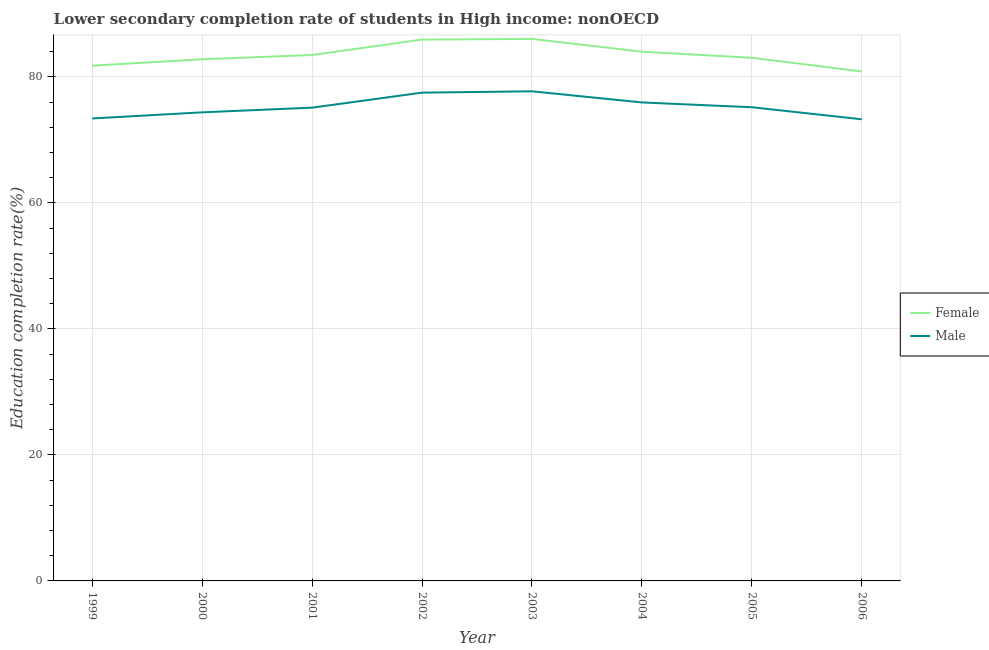Does the line corresponding to education completion rate of male students intersect with the line corresponding to education completion rate of female students?
Offer a very short reply. No. What is the education completion rate of female students in 2004?
Ensure brevity in your answer.  83.99. Across all years, what is the maximum education completion rate of male students?
Offer a very short reply. 77.71. Across all years, what is the minimum education completion rate of female students?
Your response must be concise. 80.86. In which year was the education completion rate of female students minimum?
Keep it short and to the point. 2006. What is the total education completion rate of male students in the graph?
Give a very brief answer. 602.51. What is the difference between the education completion rate of female students in 2002 and that in 2003?
Offer a very short reply. -0.11. What is the difference between the education completion rate of male students in 2000 and the education completion rate of female students in 1999?
Give a very brief answer. -7.41. What is the average education completion rate of male students per year?
Your answer should be compact. 75.31. In the year 2005, what is the difference between the education completion rate of male students and education completion rate of female students?
Provide a short and direct response. -7.86. What is the ratio of the education completion rate of female students in 2003 to that in 2004?
Make the answer very short. 1.02. Is the education completion rate of female students in 2001 less than that in 2005?
Provide a short and direct response. No. What is the difference between the highest and the second highest education completion rate of female students?
Your answer should be very brief. 0.11. What is the difference between the highest and the lowest education completion rate of male students?
Your answer should be very brief. 4.44. In how many years, is the education completion rate of female students greater than the average education completion rate of female students taken over all years?
Your answer should be very brief. 3. Is the education completion rate of female students strictly greater than the education completion rate of male students over the years?
Offer a terse response. Yes. How many lines are there?
Ensure brevity in your answer.  2. Does the graph contain any zero values?
Give a very brief answer. No. How many legend labels are there?
Offer a very short reply. 2. How are the legend labels stacked?
Your answer should be very brief. Vertical. What is the title of the graph?
Keep it short and to the point. Lower secondary completion rate of students in High income: nonOECD. What is the label or title of the X-axis?
Your answer should be very brief. Year. What is the label or title of the Y-axis?
Make the answer very short. Education completion rate(%). What is the Education completion rate(%) of Female in 1999?
Ensure brevity in your answer.  81.79. What is the Education completion rate(%) in Male in 1999?
Provide a succinct answer. 73.4. What is the Education completion rate(%) in Female in 2000?
Keep it short and to the point. 82.8. What is the Education completion rate(%) in Male in 2000?
Offer a terse response. 74.37. What is the Education completion rate(%) in Female in 2001?
Make the answer very short. 83.48. What is the Education completion rate(%) in Male in 2001?
Make the answer very short. 75.12. What is the Education completion rate(%) in Female in 2002?
Your answer should be very brief. 85.92. What is the Education completion rate(%) of Male in 2002?
Give a very brief answer. 77.5. What is the Education completion rate(%) of Female in 2003?
Keep it short and to the point. 86.03. What is the Education completion rate(%) in Male in 2003?
Offer a very short reply. 77.71. What is the Education completion rate(%) of Female in 2004?
Provide a short and direct response. 83.99. What is the Education completion rate(%) of Male in 2004?
Your answer should be compact. 75.95. What is the Education completion rate(%) in Female in 2005?
Provide a short and direct response. 83.04. What is the Education completion rate(%) in Male in 2005?
Your answer should be very brief. 75.18. What is the Education completion rate(%) of Female in 2006?
Keep it short and to the point. 80.86. What is the Education completion rate(%) of Male in 2006?
Your answer should be very brief. 73.27. Across all years, what is the maximum Education completion rate(%) of Female?
Your answer should be compact. 86.03. Across all years, what is the maximum Education completion rate(%) of Male?
Your response must be concise. 77.71. Across all years, what is the minimum Education completion rate(%) in Female?
Provide a succinct answer. 80.86. Across all years, what is the minimum Education completion rate(%) in Male?
Ensure brevity in your answer.  73.27. What is the total Education completion rate(%) in Female in the graph?
Keep it short and to the point. 667.9. What is the total Education completion rate(%) in Male in the graph?
Offer a very short reply. 602.51. What is the difference between the Education completion rate(%) in Female in 1999 and that in 2000?
Keep it short and to the point. -1.01. What is the difference between the Education completion rate(%) of Male in 1999 and that in 2000?
Your answer should be compact. -0.97. What is the difference between the Education completion rate(%) in Female in 1999 and that in 2001?
Provide a short and direct response. -1.69. What is the difference between the Education completion rate(%) of Male in 1999 and that in 2001?
Your answer should be compact. -1.71. What is the difference between the Education completion rate(%) in Female in 1999 and that in 2002?
Offer a terse response. -4.14. What is the difference between the Education completion rate(%) of Male in 1999 and that in 2002?
Your answer should be very brief. -4.1. What is the difference between the Education completion rate(%) of Female in 1999 and that in 2003?
Ensure brevity in your answer.  -4.25. What is the difference between the Education completion rate(%) in Male in 1999 and that in 2003?
Offer a terse response. -4.31. What is the difference between the Education completion rate(%) in Female in 1999 and that in 2004?
Make the answer very short. -2.21. What is the difference between the Education completion rate(%) of Male in 1999 and that in 2004?
Keep it short and to the point. -2.54. What is the difference between the Education completion rate(%) of Female in 1999 and that in 2005?
Provide a short and direct response. -1.25. What is the difference between the Education completion rate(%) in Male in 1999 and that in 2005?
Offer a terse response. -1.78. What is the difference between the Education completion rate(%) of Female in 1999 and that in 2006?
Offer a very short reply. 0.92. What is the difference between the Education completion rate(%) in Male in 1999 and that in 2006?
Give a very brief answer. 0.13. What is the difference between the Education completion rate(%) in Female in 2000 and that in 2001?
Ensure brevity in your answer.  -0.68. What is the difference between the Education completion rate(%) in Male in 2000 and that in 2001?
Give a very brief answer. -0.74. What is the difference between the Education completion rate(%) in Female in 2000 and that in 2002?
Provide a short and direct response. -3.13. What is the difference between the Education completion rate(%) in Male in 2000 and that in 2002?
Ensure brevity in your answer.  -3.13. What is the difference between the Education completion rate(%) in Female in 2000 and that in 2003?
Offer a very short reply. -3.23. What is the difference between the Education completion rate(%) of Male in 2000 and that in 2003?
Ensure brevity in your answer.  -3.34. What is the difference between the Education completion rate(%) in Female in 2000 and that in 2004?
Give a very brief answer. -1.2. What is the difference between the Education completion rate(%) in Male in 2000 and that in 2004?
Your answer should be compact. -1.57. What is the difference between the Education completion rate(%) in Female in 2000 and that in 2005?
Provide a short and direct response. -0.24. What is the difference between the Education completion rate(%) in Male in 2000 and that in 2005?
Ensure brevity in your answer.  -0.81. What is the difference between the Education completion rate(%) of Female in 2000 and that in 2006?
Provide a short and direct response. 1.94. What is the difference between the Education completion rate(%) in Male in 2000 and that in 2006?
Provide a short and direct response. 1.1. What is the difference between the Education completion rate(%) of Female in 2001 and that in 2002?
Offer a very short reply. -2.45. What is the difference between the Education completion rate(%) in Male in 2001 and that in 2002?
Keep it short and to the point. -2.38. What is the difference between the Education completion rate(%) of Female in 2001 and that in 2003?
Give a very brief answer. -2.56. What is the difference between the Education completion rate(%) of Male in 2001 and that in 2003?
Your response must be concise. -2.59. What is the difference between the Education completion rate(%) of Female in 2001 and that in 2004?
Provide a succinct answer. -0.52. What is the difference between the Education completion rate(%) of Male in 2001 and that in 2004?
Give a very brief answer. -0.83. What is the difference between the Education completion rate(%) of Female in 2001 and that in 2005?
Keep it short and to the point. 0.44. What is the difference between the Education completion rate(%) of Male in 2001 and that in 2005?
Your answer should be compact. -0.07. What is the difference between the Education completion rate(%) in Female in 2001 and that in 2006?
Make the answer very short. 2.61. What is the difference between the Education completion rate(%) in Male in 2001 and that in 2006?
Provide a short and direct response. 1.85. What is the difference between the Education completion rate(%) of Female in 2002 and that in 2003?
Your answer should be very brief. -0.11. What is the difference between the Education completion rate(%) in Male in 2002 and that in 2003?
Your answer should be compact. -0.21. What is the difference between the Education completion rate(%) of Female in 2002 and that in 2004?
Your answer should be compact. 1.93. What is the difference between the Education completion rate(%) in Male in 2002 and that in 2004?
Ensure brevity in your answer.  1.55. What is the difference between the Education completion rate(%) of Female in 2002 and that in 2005?
Ensure brevity in your answer.  2.88. What is the difference between the Education completion rate(%) in Male in 2002 and that in 2005?
Offer a very short reply. 2.32. What is the difference between the Education completion rate(%) of Female in 2002 and that in 2006?
Offer a terse response. 5.06. What is the difference between the Education completion rate(%) in Male in 2002 and that in 2006?
Ensure brevity in your answer.  4.23. What is the difference between the Education completion rate(%) in Female in 2003 and that in 2004?
Give a very brief answer. 2.04. What is the difference between the Education completion rate(%) of Male in 2003 and that in 2004?
Provide a succinct answer. 1.77. What is the difference between the Education completion rate(%) in Female in 2003 and that in 2005?
Your answer should be very brief. 2.99. What is the difference between the Education completion rate(%) of Male in 2003 and that in 2005?
Offer a terse response. 2.53. What is the difference between the Education completion rate(%) in Female in 2003 and that in 2006?
Ensure brevity in your answer.  5.17. What is the difference between the Education completion rate(%) in Male in 2003 and that in 2006?
Offer a very short reply. 4.44. What is the difference between the Education completion rate(%) of Female in 2004 and that in 2005?
Your answer should be very brief. 0.96. What is the difference between the Education completion rate(%) of Male in 2004 and that in 2005?
Provide a short and direct response. 0.76. What is the difference between the Education completion rate(%) of Female in 2004 and that in 2006?
Offer a very short reply. 3.13. What is the difference between the Education completion rate(%) in Male in 2004 and that in 2006?
Your answer should be very brief. 2.68. What is the difference between the Education completion rate(%) of Female in 2005 and that in 2006?
Keep it short and to the point. 2.18. What is the difference between the Education completion rate(%) in Male in 2005 and that in 2006?
Your answer should be compact. 1.91. What is the difference between the Education completion rate(%) in Female in 1999 and the Education completion rate(%) in Male in 2000?
Provide a succinct answer. 7.41. What is the difference between the Education completion rate(%) in Female in 1999 and the Education completion rate(%) in Male in 2001?
Make the answer very short. 6.67. What is the difference between the Education completion rate(%) in Female in 1999 and the Education completion rate(%) in Male in 2002?
Make the answer very short. 4.28. What is the difference between the Education completion rate(%) of Female in 1999 and the Education completion rate(%) of Male in 2003?
Your answer should be compact. 4.07. What is the difference between the Education completion rate(%) of Female in 1999 and the Education completion rate(%) of Male in 2004?
Offer a terse response. 5.84. What is the difference between the Education completion rate(%) of Female in 1999 and the Education completion rate(%) of Male in 2005?
Provide a succinct answer. 6.6. What is the difference between the Education completion rate(%) of Female in 1999 and the Education completion rate(%) of Male in 2006?
Provide a short and direct response. 8.51. What is the difference between the Education completion rate(%) of Female in 2000 and the Education completion rate(%) of Male in 2001?
Keep it short and to the point. 7.68. What is the difference between the Education completion rate(%) of Female in 2000 and the Education completion rate(%) of Male in 2002?
Make the answer very short. 5.3. What is the difference between the Education completion rate(%) in Female in 2000 and the Education completion rate(%) in Male in 2003?
Provide a succinct answer. 5.08. What is the difference between the Education completion rate(%) in Female in 2000 and the Education completion rate(%) in Male in 2004?
Your answer should be very brief. 6.85. What is the difference between the Education completion rate(%) in Female in 2000 and the Education completion rate(%) in Male in 2005?
Offer a terse response. 7.61. What is the difference between the Education completion rate(%) of Female in 2000 and the Education completion rate(%) of Male in 2006?
Offer a terse response. 9.53. What is the difference between the Education completion rate(%) in Female in 2001 and the Education completion rate(%) in Male in 2002?
Provide a short and direct response. 5.98. What is the difference between the Education completion rate(%) of Female in 2001 and the Education completion rate(%) of Male in 2003?
Provide a short and direct response. 5.76. What is the difference between the Education completion rate(%) of Female in 2001 and the Education completion rate(%) of Male in 2004?
Offer a very short reply. 7.53. What is the difference between the Education completion rate(%) in Female in 2001 and the Education completion rate(%) in Male in 2005?
Your answer should be compact. 8.29. What is the difference between the Education completion rate(%) of Female in 2001 and the Education completion rate(%) of Male in 2006?
Your answer should be compact. 10.21. What is the difference between the Education completion rate(%) in Female in 2002 and the Education completion rate(%) in Male in 2003?
Keep it short and to the point. 8.21. What is the difference between the Education completion rate(%) of Female in 2002 and the Education completion rate(%) of Male in 2004?
Provide a succinct answer. 9.98. What is the difference between the Education completion rate(%) of Female in 2002 and the Education completion rate(%) of Male in 2005?
Ensure brevity in your answer.  10.74. What is the difference between the Education completion rate(%) in Female in 2002 and the Education completion rate(%) in Male in 2006?
Your response must be concise. 12.65. What is the difference between the Education completion rate(%) of Female in 2003 and the Education completion rate(%) of Male in 2004?
Keep it short and to the point. 10.09. What is the difference between the Education completion rate(%) of Female in 2003 and the Education completion rate(%) of Male in 2005?
Keep it short and to the point. 10.85. What is the difference between the Education completion rate(%) of Female in 2003 and the Education completion rate(%) of Male in 2006?
Offer a very short reply. 12.76. What is the difference between the Education completion rate(%) of Female in 2004 and the Education completion rate(%) of Male in 2005?
Offer a terse response. 8.81. What is the difference between the Education completion rate(%) in Female in 2004 and the Education completion rate(%) in Male in 2006?
Offer a very short reply. 10.72. What is the difference between the Education completion rate(%) in Female in 2005 and the Education completion rate(%) in Male in 2006?
Keep it short and to the point. 9.77. What is the average Education completion rate(%) of Female per year?
Provide a short and direct response. 83.49. What is the average Education completion rate(%) in Male per year?
Make the answer very short. 75.31. In the year 1999, what is the difference between the Education completion rate(%) of Female and Education completion rate(%) of Male?
Your answer should be very brief. 8.38. In the year 2000, what is the difference between the Education completion rate(%) of Female and Education completion rate(%) of Male?
Offer a very short reply. 8.42. In the year 2001, what is the difference between the Education completion rate(%) of Female and Education completion rate(%) of Male?
Offer a terse response. 8.36. In the year 2002, what is the difference between the Education completion rate(%) of Female and Education completion rate(%) of Male?
Your response must be concise. 8.42. In the year 2003, what is the difference between the Education completion rate(%) in Female and Education completion rate(%) in Male?
Offer a very short reply. 8.32. In the year 2004, what is the difference between the Education completion rate(%) in Female and Education completion rate(%) in Male?
Make the answer very short. 8.05. In the year 2005, what is the difference between the Education completion rate(%) of Female and Education completion rate(%) of Male?
Offer a very short reply. 7.86. In the year 2006, what is the difference between the Education completion rate(%) in Female and Education completion rate(%) in Male?
Ensure brevity in your answer.  7.59. What is the ratio of the Education completion rate(%) of Female in 1999 to that in 2000?
Offer a very short reply. 0.99. What is the ratio of the Education completion rate(%) in Male in 1999 to that in 2000?
Make the answer very short. 0.99. What is the ratio of the Education completion rate(%) in Female in 1999 to that in 2001?
Offer a terse response. 0.98. What is the ratio of the Education completion rate(%) of Male in 1999 to that in 2001?
Offer a terse response. 0.98. What is the ratio of the Education completion rate(%) in Female in 1999 to that in 2002?
Your response must be concise. 0.95. What is the ratio of the Education completion rate(%) in Male in 1999 to that in 2002?
Your answer should be very brief. 0.95. What is the ratio of the Education completion rate(%) of Female in 1999 to that in 2003?
Keep it short and to the point. 0.95. What is the ratio of the Education completion rate(%) in Male in 1999 to that in 2003?
Make the answer very short. 0.94. What is the ratio of the Education completion rate(%) in Female in 1999 to that in 2004?
Your answer should be compact. 0.97. What is the ratio of the Education completion rate(%) of Male in 1999 to that in 2004?
Your answer should be very brief. 0.97. What is the ratio of the Education completion rate(%) in Female in 1999 to that in 2005?
Offer a very short reply. 0.98. What is the ratio of the Education completion rate(%) in Male in 1999 to that in 2005?
Your response must be concise. 0.98. What is the ratio of the Education completion rate(%) in Female in 1999 to that in 2006?
Make the answer very short. 1.01. What is the ratio of the Education completion rate(%) of Male in 1999 to that in 2006?
Make the answer very short. 1. What is the ratio of the Education completion rate(%) of Male in 2000 to that in 2001?
Make the answer very short. 0.99. What is the ratio of the Education completion rate(%) of Female in 2000 to that in 2002?
Your answer should be compact. 0.96. What is the ratio of the Education completion rate(%) in Male in 2000 to that in 2002?
Offer a very short reply. 0.96. What is the ratio of the Education completion rate(%) of Female in 2000 to that in 2003?
Offer a very short reply. 0.96. What is the ratio of the Education completion rate(%) in Male in 2000 to that in 2003?
Make the answer very short. 0.96. What is the ratio of the Education completion rate(%) in Female in 2000 to that in 2004?
Your response must be concise. 0.99. What is the ratio of the Education completion rate(%) of Male in 2000 to that in 2004?
Ensure brevity in your answer.  0.98. What is the ratio of the Education completion rate(%) of Male in 2000 to that in 2005?
Ensure brevity in your answer.  0.99. What is the ratio of the Education completion rate(%) in Female in 2000 to that in 2006?
Make the answer very short. 1.02. What is the ratio of the Education completion rate(%) of Male in 2000 to that in 2006?
Your answer should be very brief. 1.02. What is the ratio of the Education completion rate(%) of Female in 2001 to that in 2002?
Your answer should be very brief. 0.97. What is the ratio of the Education completion rate(%) in Male in 2001 to that in 2002?
Ensure brevity in your answer.  0.97. What is the ratio of the Education completion rate(%) of Female in 2001 to that in 2003?
Offer a terse response. 0.97. What is the ratio of the Education completion rate(%) of Male in 2001 to that in 2003?
Your answer should be very brief. 0.97. What is the ratio of the Education completion rate(%) of Male in 2001 to that in 2004?
Ensure brevity in your answer.  0.99. What is the ratio of the Education completion rate(%) in Female in 2001 to that in 2005?
Keep it short and to the point. 1.01. What is the ratio of the Education completion rate(%) of Female in 2001 to that in 2006?
Offer a terse response. 1.03. What is the ratio of the Education completion rate(%) in Male in 2001 to that in 2006?
Give a very brief answer. 1.03. What is the ratio of the Education completion rate(%) of Male in 2002 to that in 2003?
Ensure brevity in your answer.  1. What is the ratio of the Education completion rate(%) of Female in 2002 to that in 2004?
Your answer should be compact. 1.02. What is the ratio of the Education completion rate(%) of Male in 2002 to that in 2004?
Your answer should be very brief. 1.02. What is the ratio of the Education completion rate(%) of Female in 2002 to that in 2005?
Ensure brevity in your answer.  1.03. What is the ratio of the Education completion rate(%) of Male in 2002 to that in 2005?
Provide a succinct answer. 1.03. What is the ratio of the Education completion rate(%) in Female in 2002 to that in 2006?
Offer a terse response. 1.06. What is the ratio of the Education completion rate(%) in Male in 2002 to that in 2006?
Your response must be concise. 1.06. What is the ratio of the Education completion rate(%) in Female in 2003 to that in 2004?
Keep it short and to the point. 1.02. What is the ratio of the Education completion rate(%) of Male in 2003 to that in 2004?
Your response must be concise. 1.02. What is the ratio of the Education completion rate(%) of Female in 2003 to that in 2005?
Give a very brief answer. 1.04. What is the ratio of the Education completion rate(%) in Male in 2003 to that in 2005?
Make the answer very short. 1.03. What is the ratio of the Education completion rate(%) in Female in 2003 to that in 2006?
Provide a succinct answer. 1.06. What is the ratio of the Education completion rate(%) in Male in 2003 to that in 2006?
Offer a terse response. 1.06. What is the ratio of the Education completion rate(%) in Female in 2004 to that in 2005?
Give a very brief answer. 1.01. What is the ratio of the Education completion rate(%) in Male in 2004 to that in 2005?
Keep it short and to the point. 1.01. What is the ratio of the Education completion rate(%) in Female in 2004 to that in 2006?
Your answer should be compact. 1.04. What is the ratio of the Education completion rate(%) of Male in 2004 to that in 2006?
Give a very brief answer. 1.04. What is the ratio of the Education completion rate(%) in Female in 2005 to that in 2006?
Keep it short and to the point. 1.03. What is the ratio of the Education completion rate(%) in Male in 2005 to that in 2006?
Provide a succinct answer. 1.03. What is the difference between the highest and the second highest Education completion rate(%) of Female?
Keep it short and to the point. 0.11. What is the difference between the highest and the second highest Education completion rate(%) in Male?
Keep it short and to the point. 0.21. What is the difference between the highest and the lowest Education completion rate(%) in Female?
Provide a succinct answer. 5.17. What is the difference between the highest and the lowest Education completion rate(%) in Male?
Offer a terse response. 4.44. 